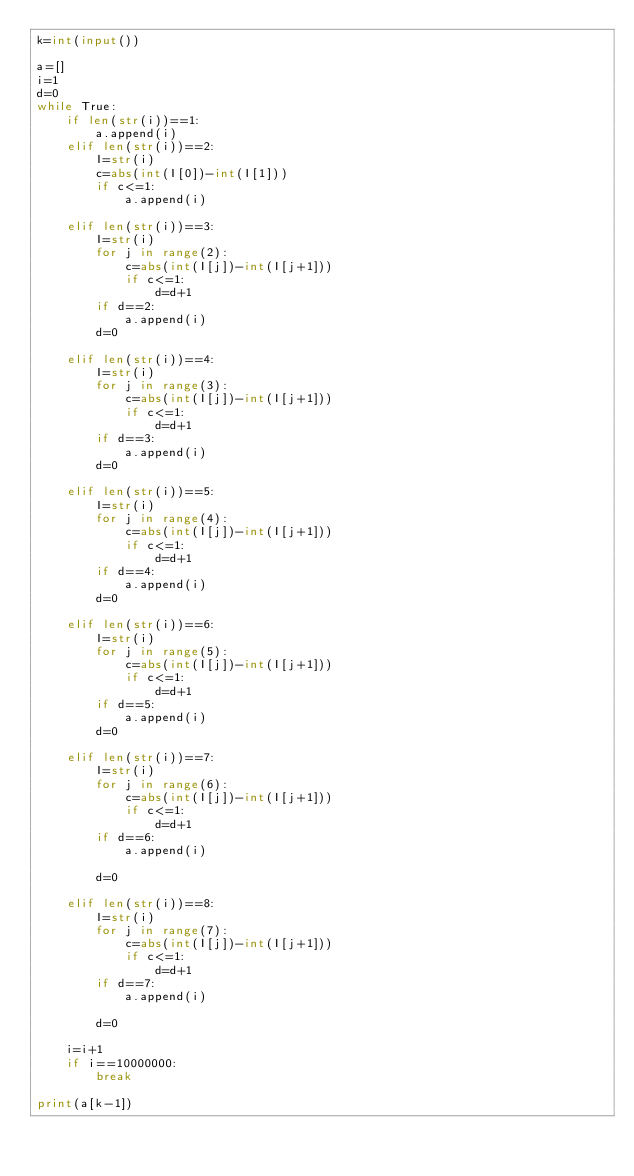Convert code to text. <code><loc_0><loc_0><loc_500><loc_500><_Python_>k=int(input())

a=[]
i=1
d=0
while True:
    if len(str(i))==1:
        a.append(i)
    elif len(str(i))==2:
        I=str(i)
        c=abs(int(I[0])-int(I[1]))
        if c<=1:
            a.append(i)   
            
    elif len(str(i))==3:
        I=str(i)
        for j in range(2):
            c=abs(int(I[j])-int(I[j+1]))
            if c<=1:
                d=d+1
        if d==2:
            a.append(i)
        d=0
        
    elif len(str(i))==4:
        I=str(i)
        for j in range(3):
            c=abs(int(I[j])-int(I[j+1]))
            if c<=1:
                d=d+1
        if d==3:
            a.append(i) 
        d=0
        
    elif len(str(i))==5:
        I=str(i)
        for j in range(4):
            c=abs(int(I[j])-int(I[j+1]))
            if c<=1:
                d=d+1
        if d==4:
            a.append(i)   
        d=0
        
    elif len(str(i))==6:
        I=str(i)
        for j in range(5):
            c=abs(int(I[j])-int(I[j+1]))
            if c<=1:
                d=d+1
        if d==5:
            a.append(i)
        d=0
    
    elif len(str(i))==7:
        I=str(i)
        for j in range(6):
            c=abs(int(I[j])-int(I[j+1]))
            if c<=1:
                d=d+1
        if d==6:
            a.append(i)
            
        d=0    
        
    elif len(str(i))==8:
        I=str(i)
        for j in range(7):
            c=abs(int(I[j])-int(I[j+1]))
            if c<=1:
                d=d+1
        if d==7:
            a.append(i)
            
        d=0    
        
    i=i+1
    if i==10000000:
        break

print(a[k-1])</code> 